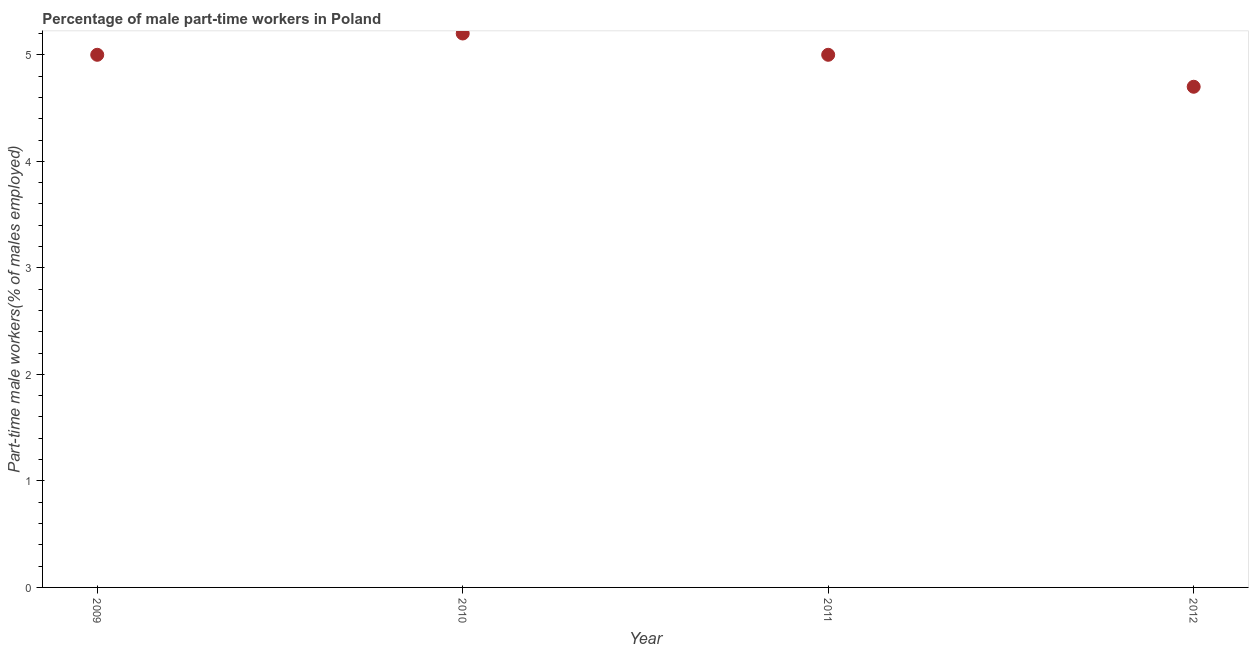What is the percentage of part-time male workers in 2009?
Make the answer very short. 5. Across all years, what is the maximum percentage of part-time male workers?
Give a very brief answer. 5.2. Across all years, what is the minimum percentage of part-time male workers?
Offer a very short reply. 4.7. In which year was the percentage of part-time male workers minimum?
Offer a very short reply. 2012. What is the sum of the percentage of part-time male workers?
Keep it short and to the point. 19.9. What is the difference between the percentage of part-time male workers in 2009 and 2010?
Offer a very short reply. -0.2. What is the average percentage of part-time male workers per year?
Your answer should be very brief. 4.97. What is the median percentage of part-time male workers?
Give a very brief answer. 5. In how many years, is the percentage of part-time male workers greater than 4.8 %?
Make the answer very short. 3. Is the difference between the percentage of part-time male workers in 2010 and 2012 greater than the difference between any two years?
Ensure brevity in your answer.  Yes. What is the difference between the highest and the second highest percentage of part-time male workers?
Your answer should be very brief. 0.2. Is the sum of the percentage of part-time male workers in 2011 and 2012 greater than the maximum percentage of part-time male workers across all years?
Make the answer very short. Yes. What is the difference between the highest and the lowest percentage of part-time male workers?
Offer a very short reply. 0.5. Does the percentage of part-time male workers monotonically increase over the years?
Ensure brevity in your answer.  No. How many dotlines are there?
Offer a terse response. 1. What is the title of the graph?
Give a very brief answer. Percentage of male part-time workers in Poland. What is the label or title of the Y-axis?
Your answer should be very brief. Part-time male workers(% of males employed). What is the Part-time male workers(% of males employed) in 2010?
Keep it short and to the point. 5.2. What is the Part-time male workers(% of males employed) in 2012?
Your answer should be compact. 4.7. What is the difference between the Part-time male workers(% of males employed) in 2009 and 2011?
Provide a succinct answer. 0. What is the difference between the Part-time male workers(% of males employed) in 2010 and 2011?
Your answer should be compact. 0.2. What is the ratio of the Part-time male workers(% of males employed) in 2009 to that in 2011?
Provide a succinct answer. 1. What is the ratio of the Part-time male workers(% of males employed) in 2009 to that in 2012?
Offer a very short reply. 1.06. What is the ratio of the Part-time male workers(% of males employed) in 2010 to that in 2012?
Give a very brief answer. 1.11. What is the ratio of the Part-time male workers(% of males employed) in 2011 to that in 2012?
Your response must be concise. 1.06. 